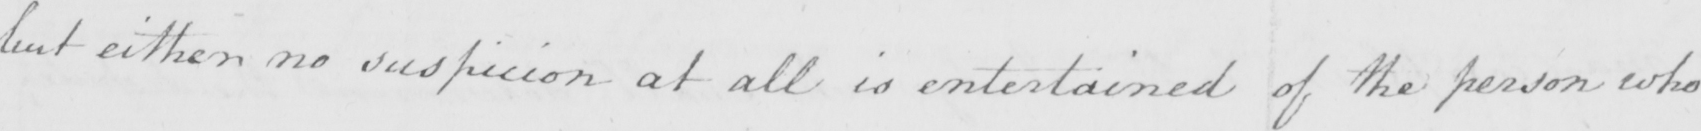Can you tell me what this handwritten text says? but either no suspicion at all is entertained of the person who 